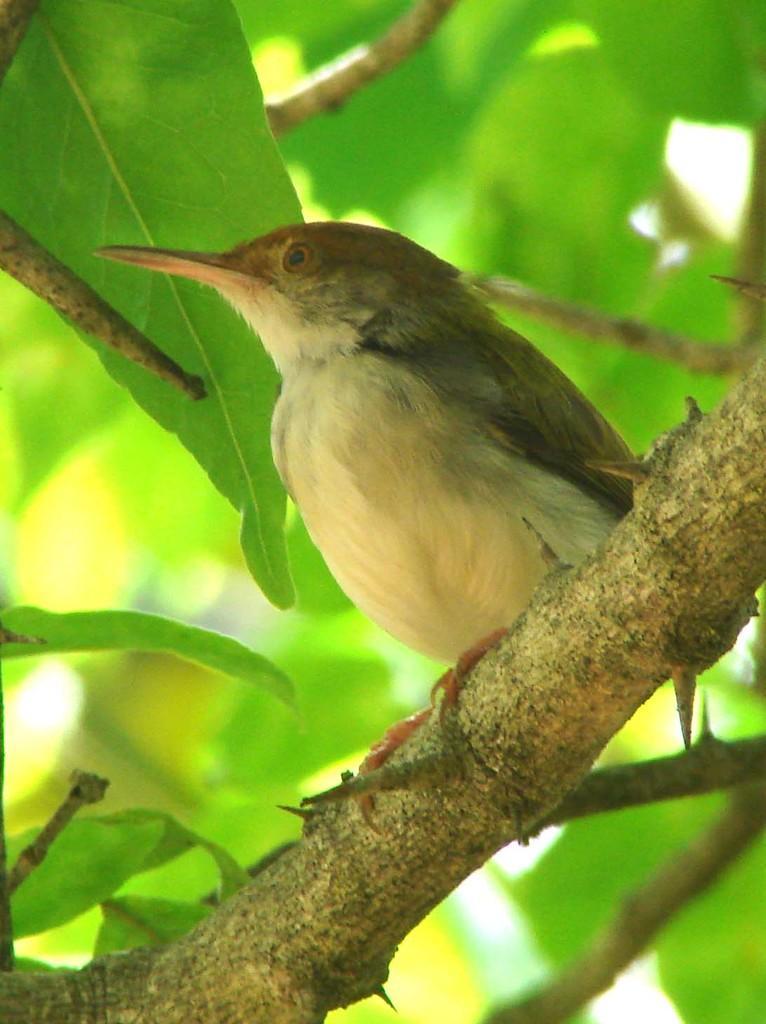Describe this image in one or two sentences. In the center of the image, we can see a bird on the stem and in the background, there are leaves. 